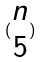Convert formula to latex. <formula><loc_0><loc_0><loc_500><loc_500>( \begin{matrix} n \\ 5 \end{matrix} )</formula> 